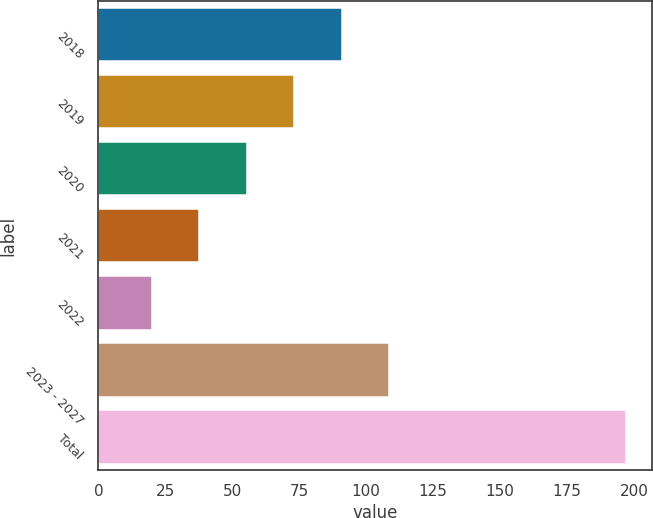<chart> <loc_0><loc_0><loc_500><loc_500><bar_chart><fcel>2018<fcel>2019<fcel>2020<fcel>2021<fcel>2022<fcel>2023 - 2027<fcel>Total<nl><fcel>90.8<fcel>73.1<fcel>55.4<fcel>37.7<fcel>20<fcel>108.5<fcel>197<nl></chart> 